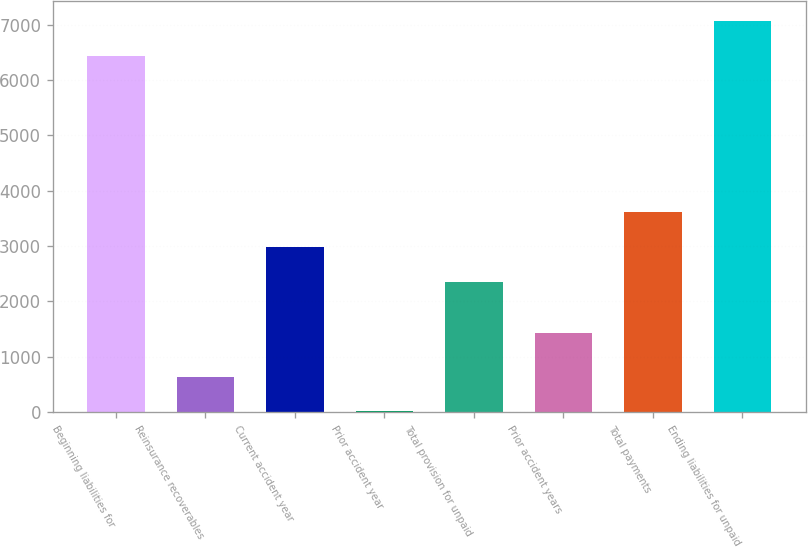<chart> <loc_0><loc_0><loc_500><loc_500><bar_chart><fcel>Beginning liabilities for<fcel>Reinsurance recoverables<fcel>Current accident year<fcel>Prior accident year<fcel>Total provision for unpaid<fcel>Prior accident years<fcel>Total payments<fcel>Ending liabilities for unpaid<nl><fcel>6442.7<fcel>640.7<fcel>2988.7<fcel>11<fcel>2359<fcel>1426<fcel>3618.4<fcel>7072.4<nl></chart> 